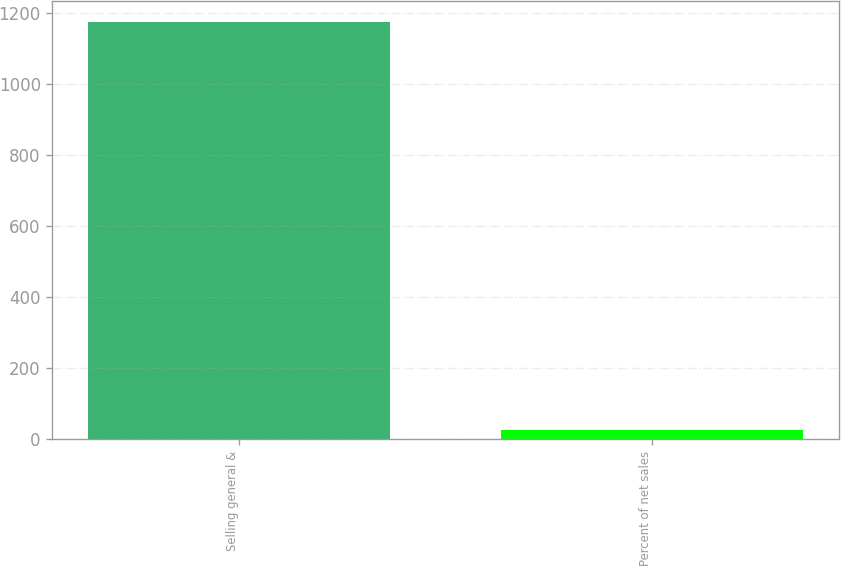Convert chart to OTSL. <chart><loc_0><loc_0><loc_500><loc_500><bar_chart><fcel>Selling general &<fcel>Percent of net sales<nl><fcel>1175<fcel>26.6<nl></chart> 